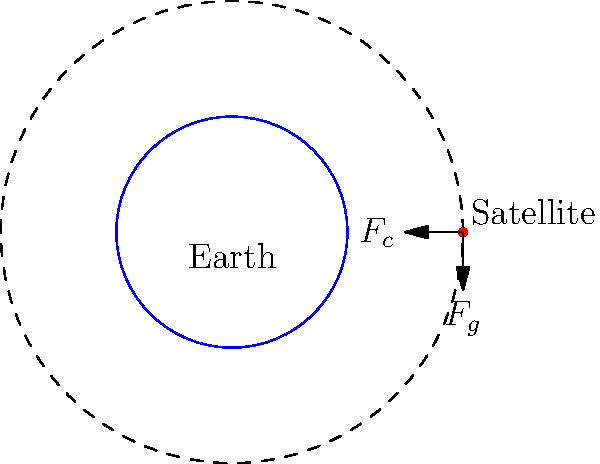In crafting a speech about space exploration and satellite technology, you need to explain the forces acting on a satellite in orbit around Earth. Given that the satellite maintains a circular orbit, what is the relationship between the gravitational force ($F_g$) and the centripetal force ($F_c$) acting on the satellite? To understand the relationship between the gravitational force and the centripetal force on a satellite in circular orbit, let's follow these steps:

1. Gravitational force ($F_g$): This is the force of attraction between the Earth and the satellite. It's given by Newton's law of gravitation:

   $$F_g = G\frac{M_E m}{r^2}$$

   where $G$ is the gravitational constant, $M_E$ is the mass of Earth, $m$ is the mass of the satellite, and $r$ is the distance from the center of Earth to the satellite.

2. Centripetal force ($F_c$): This is the force required to keep an object moving in a circular path. For a satellite in orbit, it's given by:

   $$F_c = \frac{mv^2}{r}$$

   where $m$ is the mass of the satellite, $v$ is its orbital velocity, and $r$ is the radius of the orbit.

3. For a stable circular orbit, the gravitational force provides the centripetal force. This means:

   $$F_g = F_c$$

4. Therefore, for a satellite to maintain a stable circular orbit, the gravitational force must be exactly equal to the centripetal force required for that orbit.

5. This equality is what keeps the satellite in its orbit without falling to Earth or escaping into space.

In summary, for a satellite in a stable circular orbit around Earth, the gravitational force and the centripetal force are equal in magnitude but opposite in direction.
Answer: $F_g = F_c$ 